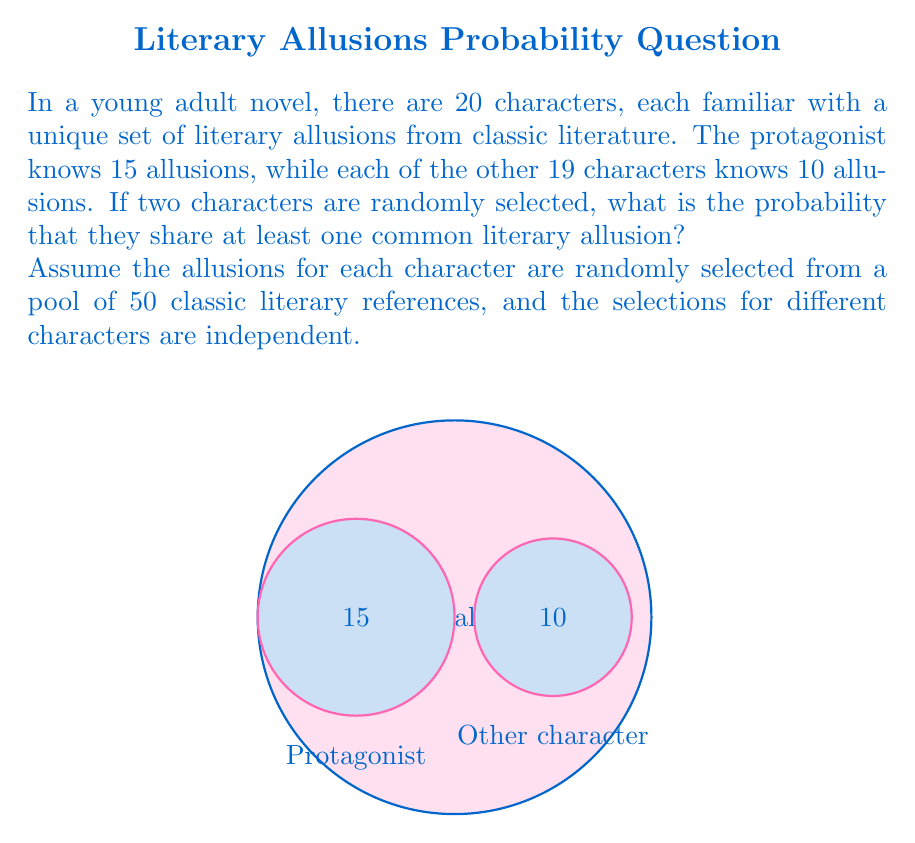Teach me how to tackle this problem. Let's approach this step-by-step:

1) First, we need to calculate the probability that two randomly selected characters do not share any allusions. Then we can subtract this from 1 to get the probability that they do share at least one allusion.

2) The probability of no shared allusions depends on whether the protagonist is one of the selected characters. Let's consider both cases:

   Case 1: Protagonist and another character
   Case 2: Two characters other than the protagonist

3) Case 1 (Protagonist and another character):
   - Probability of selecting the protagonist: $\frac{1}{20}$
   - Probability of selecting another character given the protagonist is selected: $\frac{19}{19} = 1$
   - Probability of no shared allusions:
     $$P(\text{no shared | Case 1}) = \left(\frac{35}{50}\right)^{10}$$

4) Case 2 (Two characters other than the protagonist):
   - Probability of selecting two non-protagonist characters: $\frac{19}{20} \cdot \frac{18}{19} = \frac{18}{20}$
   - Probability of no shared allusions:
     $$P(\text{no shared | Case 2}) = \left(\frac{40}{50}\right)^{10}$$

5) Total probability of no shared allusions:
   $$P(\text{no shared}) = \frac{1}{20} \cdot \left(\frac{35}{50}\right)^{10} + \frac{18}{20} \cdot \left(\frac{40}{50}\right)^{10}$$

6) Therefore, the probability of sharing at least one allusion is:
   $$P(\text{shared}) = 1 - \left[\frac{1}{20} \cdot \left(\frac{35}{50}\right)^{10} + \frac{18}{20} \cdot \left(\frac{40}{50}\right)^{10}\right]$$

7) Calculating this:
   $$P(\text{shared}) = 1 - [0.05 \cdot 0.0138 + 0.9 \cdot 0.1074] = 1 - 0.0969 = 0.9031$$
Answer: $0.9031$ or $90.31\%$ 